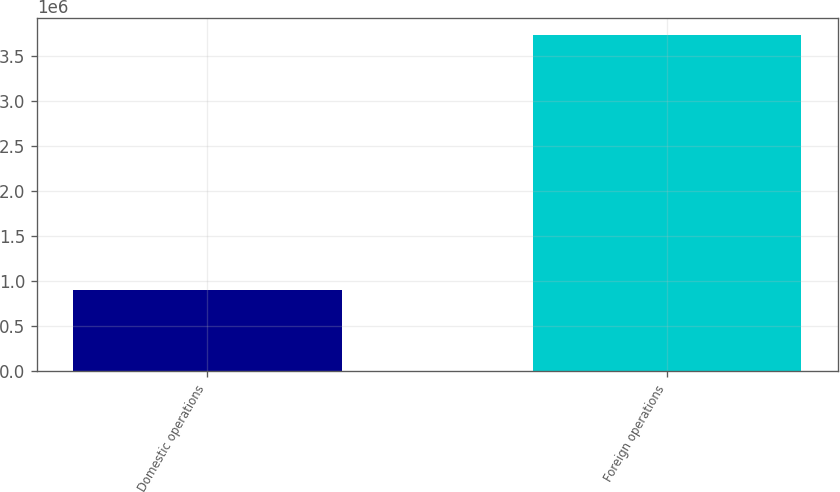<chart> <loc_0><loc_0><loc_500><loc_500><bar_chart><fcel>Domestic operations<fcel>Foreign operations<nl><fcel>902613<fcel>3.73424e+06<nl></chart> 